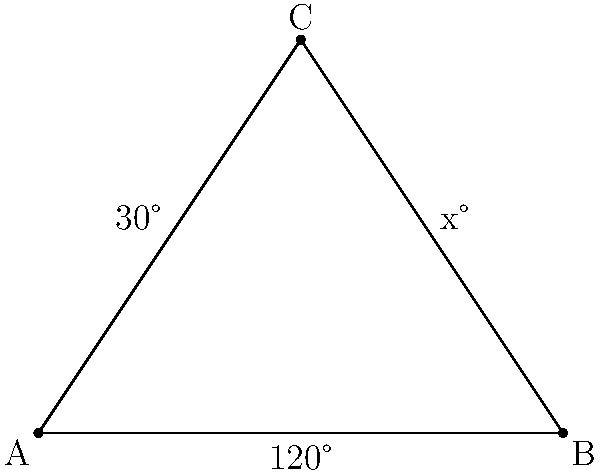A famous wrestler's signature pose forms a triangle with his arms and torso. The angle between his legs is 120°, and the angle between his left arm and torso is 30°. If we consider this pose as a triangle ABC, what is the measure of the angle between his right arm and torso (represented by angle x° in the diagram)? Let's approach this step-by-step:

1) In any triangle, the sum of all interior angles is always 180°.

2) We are given that one angle of the triangle (at point B) is 120°.

3) We are also told that another angle (at point A) is 30°.

4) Let's call the unknown angle (at point C) x°.

5) We can set up an equation based on the fact that the sum of all angles in a triangle is 180°:

   $$120° + 30° + x° = 180°$$

6) Simplifying the left side of the equation:

   $$150° + x° = 180°$$

7) Subtracting 150° from both sides:

   $$x° = 180° - 150° = 30°$$

Therefore, the measure of angle x is 30°.
Answer: 30° 